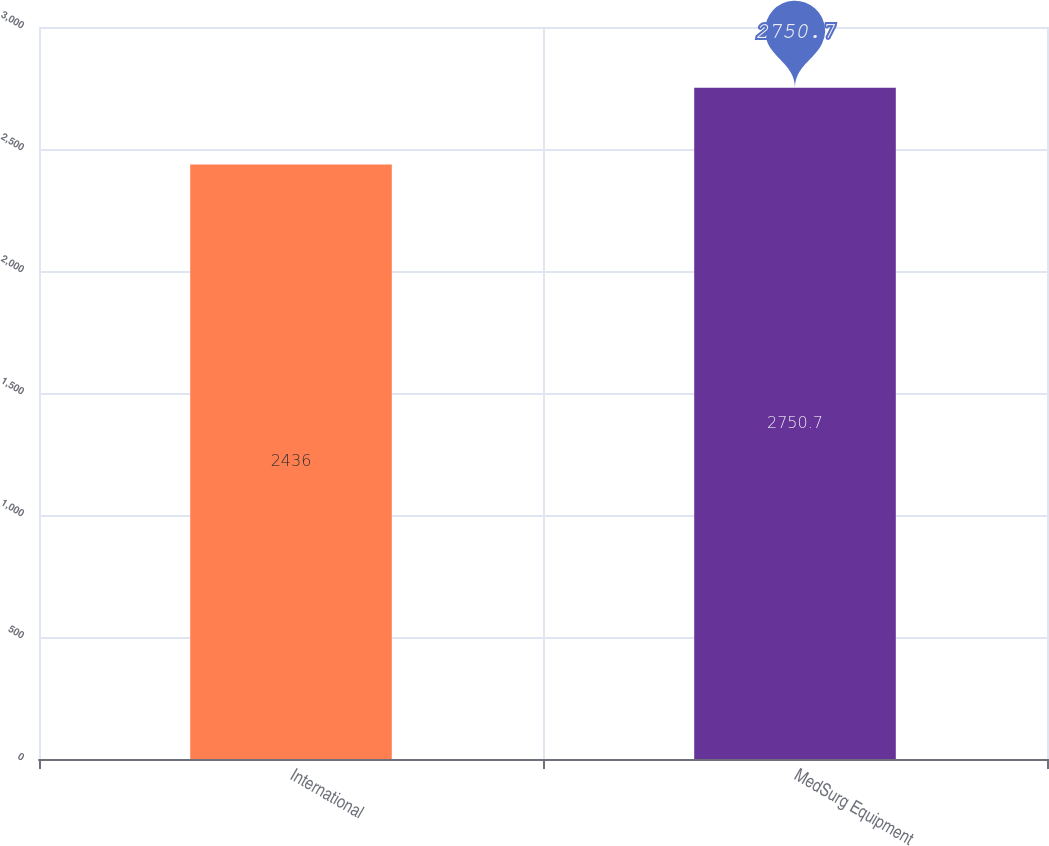Convert chart to OTSL. <chart><loc_0><loc_0><loc_500><loc_500><bar_chart><fcel>International<fcel>MedSurg Equipment<nl><fcel>2436<fcel>2750.7<nl></chart> 